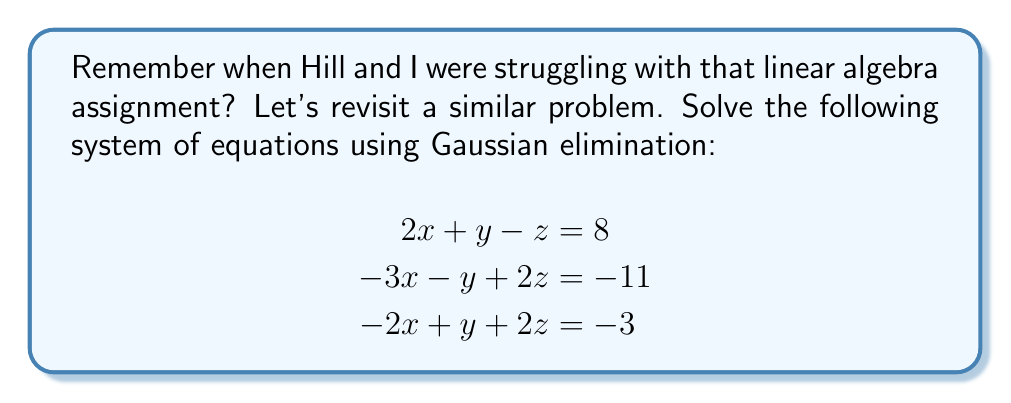Could you help me with this problem? Let's solve this step-by-step using Gaussian elimination:

1) First, we set up the augmented matrix:

   $$\begin{bmatrix}
   2 & 1 & -1 & | & 8 \\
   -3 & -1 & 2 & | & -11 \\
   -2 & 1 & 2 & | & -3
   \end{bmatrix}$$

2) We'll use the first row as our pivot. Add 3/2 times the first row to the second row:

   $$\begin{bmatrix}
   2 & 1 & -1 & | & 8 \\
   0 & \frac{1}{2} & \frac{1}{2} & | & 1 \\
   -2 & 1 & 2 & | & -3
   \end{bmatrix}$$

3) Now, add the first row to the third row:

   $$\begin{bmatrix}
   2 & 1 & -1 & | & 8 \\
   0 & \frac{1}{2} & \frac{1}{2} & | & 1 \\
   0 & 2 & 1 & | & 5
   \end{bmatrix}$$

4) Multiply the second row by 2 to eliminate fractions:

   $$\begin{bmatrix}
   2 & 1 & -1 & | & 8 \\
   0 & 1 & 1 & | & 2 \\
   0 & 2 & 1 & | & 5
   \end{bmatrix}$$

5) Subtract 2 times the second row from the third row:

   $$\begin{bmatrix}
   2 & 1 & -1 & | & 8 \\
   0 & 1 & 1 & | & 2 \\
   0 & 0 & -1 & | & 1
   \end{bmatrix}$$

6) Now we have an upper triangular matrix. We can solve by back-substitution:

   From the last row: $z = -1$
   
   From the second row: $y + z = 2$, so $y = 3$
   
   From the first row: $2x + y - z = 8$, so $2x + 3 + 1 = 8$, therefore $x = 2$

Thus, the solution is $x = 2$, $y = 3$, and $z = -1$.
Answer: $(2, 3, -1)$ 